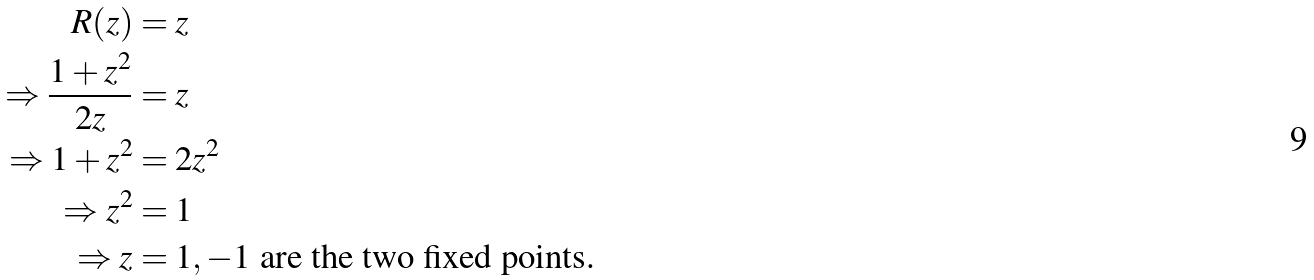Convert formula to latex. <formula><loc_0><loc_0><loc_500><loc_500>R ( z ) & = z \\ \Rightarrow \frac { 1 + z ^ { 2 } } { 2 z } & = z \\ \Rightarrow 1 + z ^ { 2 } & = 2 z ^ { 2 } \\ \Rightarrow z ^ { 2 } & = 1 \\ \Rightarrow z & = 1 , { - } 1 \text { are the two fixed points.}</formula> 